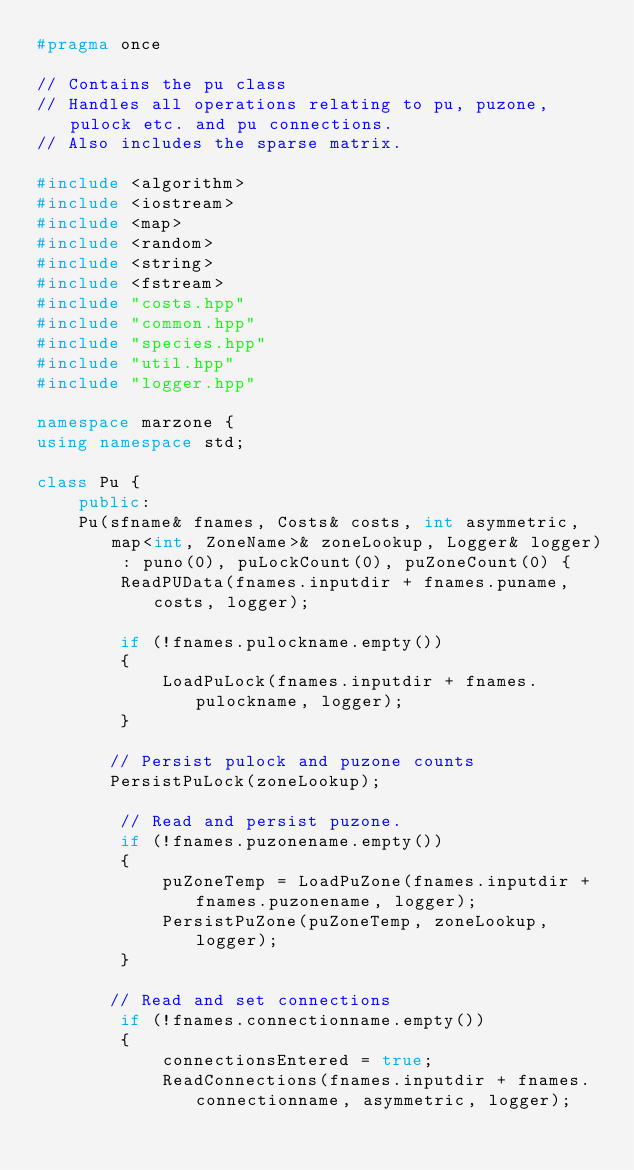Convert code to text. <code><loc_0><loc_0><loc_500><loc_500><_C++_>#pragma once

// Contains the pu class
// Handles all operations relating to pu, puzone, pulock etc. and pu connections.
// Also includes the sparse matrix. 

#include <algorithm>
#include <iostream>
#include <map>
#include <random>
#include <string>
#include <fstream>
#include "costs.hpp"
#include "common.hpp"
#include "species.hpp"
#include "util.hpp"
#include "logger.hpp"

namespace marzone {
using namespace std;

class Pu {
    public:
    Pu(sfname& fnames, Costs& costs, int asymmetric, map<int, ZoneName>& zoneLookup, Logger& logger) : puno(0), puLockCount(0), puZoneCount(0) {
        ReadPUData(fnames.inputdir + fnames.puname, costs, logger);

        if (!fnames.pulockname.empty())
        {
            LoadPuLock(fnames.inputdir + fnames.pulockname, logger);
        }

       // Persist pulock and puzone counts
       PersistPuLock(zoneLookup);

        // Read and persist puzone.
        if (!fnames.puzonename.empty())
        {
            puZoneTemp = LoadPuZone(fnames.inputdir + fnames.puzonename, logger);
            PersistPuZone(puZoneTemp, zoneLookup, logger);
        }

       // Read and set connections
        if (!fnames.connectionname.empty())
        {
            connectionsEntered = true;
            ReadConnections(fnames.inputdir + fnames.connectionname, asymmetric, logger);</code> 